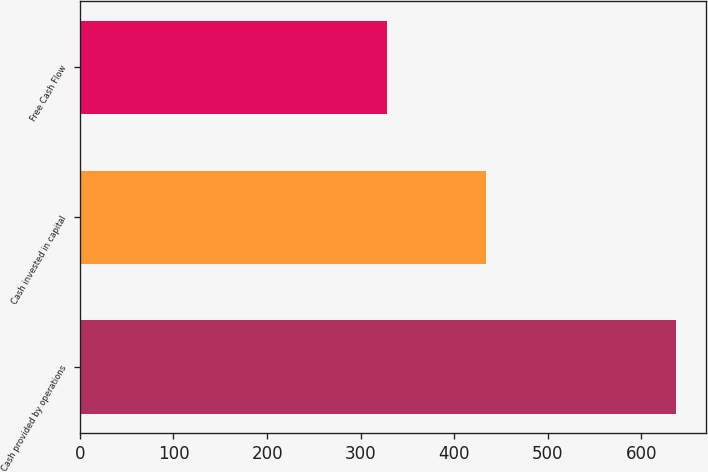Convert chart. <chart><loc_0><loc_0><loc_500><loc_500><bar_chart><fcel>Cash provided by operations<fcel>Cash invested in capital<fcel>Free Cash Flow<nl><fcel>637<fcel>434<fcel>328<nl></chart> 